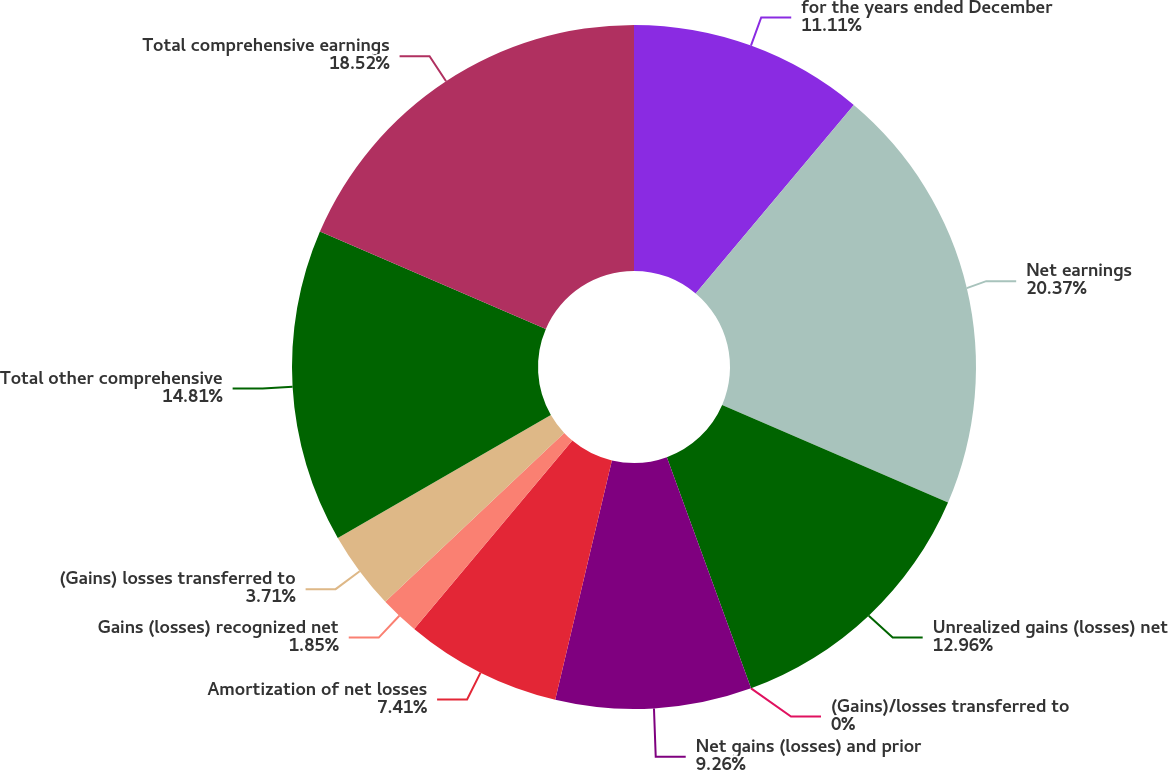Convert chart. <chart><loc_0><loc_0><loc_500><loc_500><pie_chart><fcel>for the years ended December<fcel>Net earnings<fcel>Unrealized gains (losses) net<fcel>(Gains)/losses transferred to<fcel>Net gains (losses) and prior<fcel>Amortization of net losses<fcel>Gains (losses) recognized net<fcel>(Gains) losses transferred to<fcel>Total other comprehensive<fcel>Total comprehensive earnings<nl><fcel>11.11%<fcel>20.37%<fcel>12.96%<fcel>0.0%<fcel>9.26%<fcel>7.41%<fcel>1.85%<fcel>3.71%<fcel>14.81%<fcel>18.52%<nl></chart> 